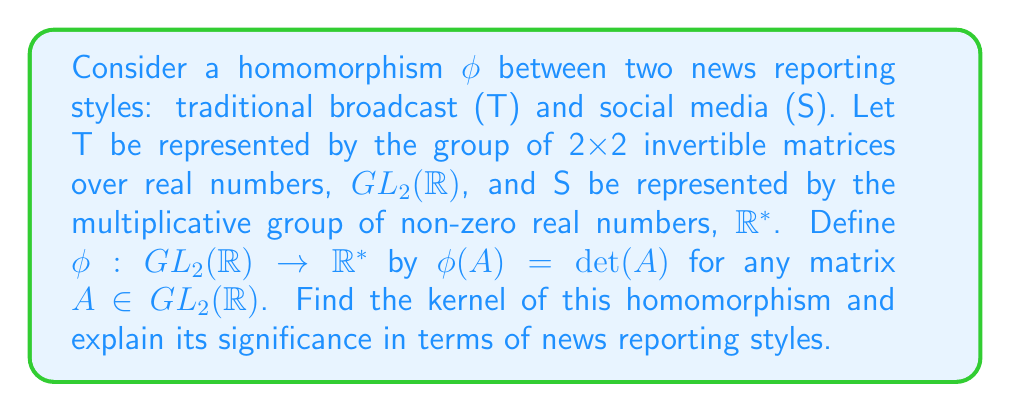Could you help me with this problem? To find the kernel of the homomorphism $\phi$, we need to determine all elements in $GL_2(\mathbb{R})$ that map to the identity element in $\mathbb{R}^*$.

1) The identity element in $\mathbb{R}^*$ is 1.

2) We need to find all matrices $A \in GL_2(\mathbb{R})$ such that $\phi(A) = \det(A) = 1$.

3) The set of all 2x2 matrices with determinant 1 is known as the special linear group $SL_2(\mathbb{R})$.

4) Therefore, $\ker(\phi) = SL_2(\mathbb{R})$.

In terms of news reporting styles, this kernel represents the set of all transformations in traditional broadcast reporting that preserve the "volume" or "impact" of the news when translated to social media. Elements in $SL_2(\mathbb{R})$ can be thought of as transformations that change the format or presentation of the news without altering its fundamental importance or reach.

For example, consider the matrix:

$$A = \begin{pmatrix} 
a & b \\
c & d 
\end{pmatrix}$$

For $A$ to be in $SL_2(\mathbb{R})$, we must have $ad - bc = 1$. This could represent a transformation where:
- $a$ represents the depth of content
- $b$ represents the visual appeal
- $c$ represents the brevity
- $d$ represents the timeliness

The condition $ad - bc = 1$ ensures that any increase in one aspect is balanced by changes in the others, maintaining the overall impact of the news story across both traditional and social media platforms.
Answer: The kernel of the homomorphism $\phi$ is $SL_2(\mathbb{R})$, the special linear group of 2x2 matrices with determinant 1. 